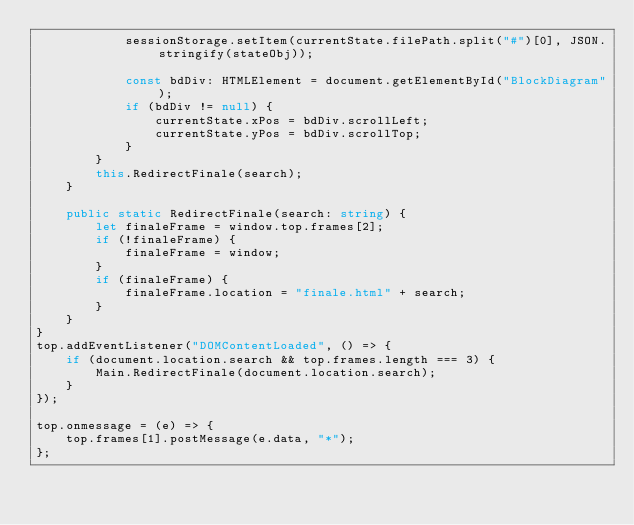Convert code to text. <code><loc_0><loc_0><loc_500><loc_500><_TypeScript_>            sessionStorage.setItem(currentState.filePath.split("#")[0], JSON.stringify(stateObj));

            const bdDiv: HTMLElement = document.getElementById("BlockDiagram");
            if (bdDiv != null) {
                currentState.xPos = bdDiv.scrollLeft;
                currentState.yPos = bdDiv.scrollTop;
            }
        }
        this.RedirectFinale(search);
    }

    public static RedirectFinale(search: string) {
        let finaleFrame = window.top.frames[2];
        if (!finaleFrame) {
            finaleFrame = window;
        }
        if (finaleFrame) {
            finaleFrame.location = "finale.html" + search;
        }
    }
}
top.addEventListener("DOMContentLoaded", () => {
    if (document.location.search && top.frames.length === 3) {
        Main.RedirectFinale(document.location.search);
    }
});

top.onmessage = (e) => {
    top.frames[1].postMessage(e.data, "*");
};
</code> 